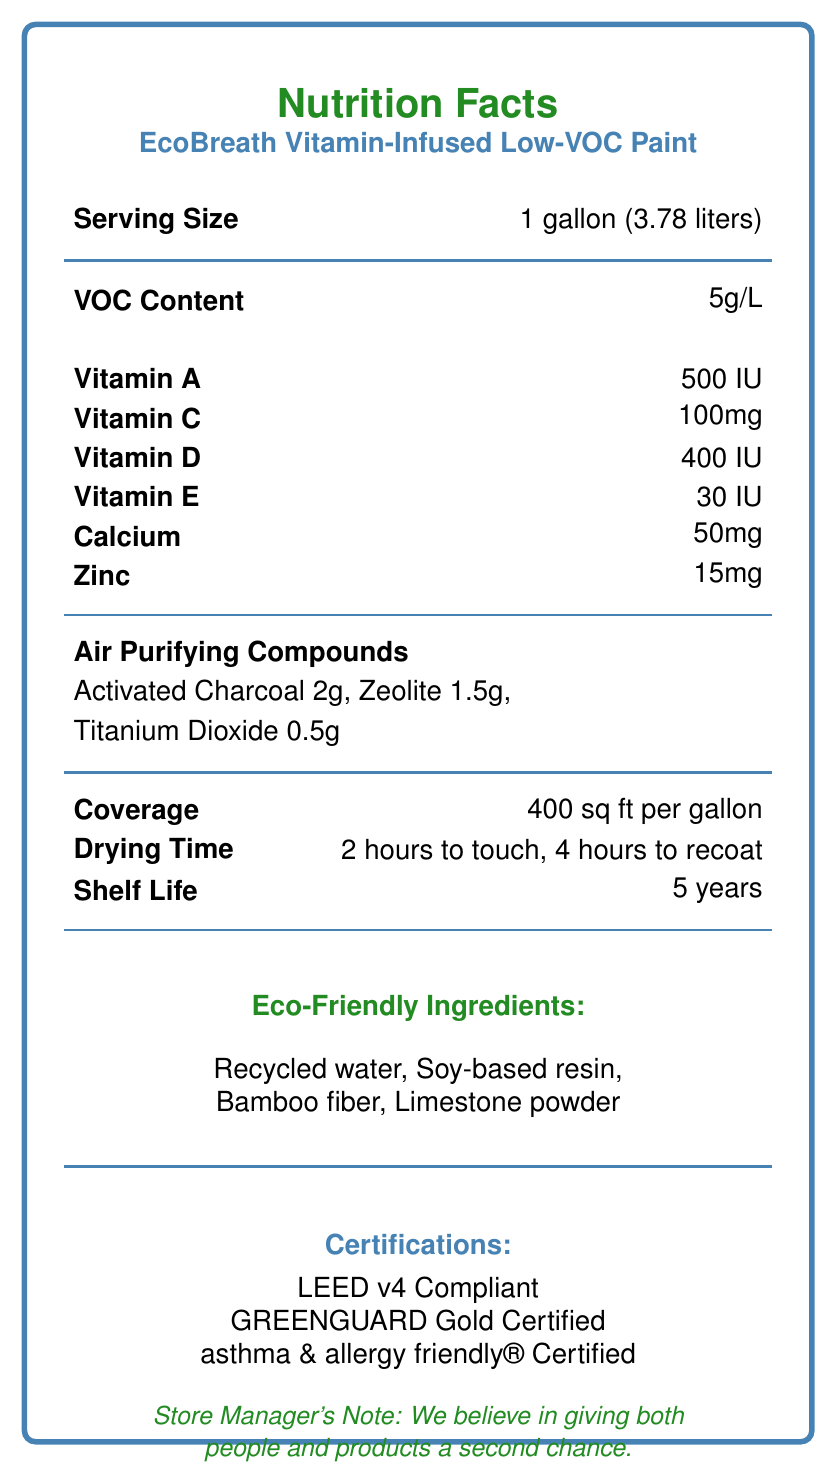what is the VOC content of the paint? The VOC content is listed under the "VOC Content" section in the document.
Answer: 5g/L what is the serving size for this paint? The serving size is listed as "1 gallon (3.78 liters)" in the document.
Answer: 1 gallon (3.78 liters) how many vitamins are listed in the nutrition facts? The nutrition facts list Vitamin A, Vitamin C, Vitamin D, and Vitamin E.
Answer: 4 how long does it take for the paint to dry to touch? The drying time to touch is stated as "2 hours" under the "Drying Time" section.
Answer: 2 hours where is the paint made? The document indicates that the paint is made in the USA.
Answer: USA which of these is not listed as an air purifying compound in the paint? A. Activated Charcoal B. Zeolite C. Bamboo Fiber D. Titanium Dioxide The document lists Activated Charcoal, Zeolite, and Titanium Dioxide as air purifying compounds but not Bamboo Fiber.
Answer: C. Bamboo Fiber which certification is not mentioned in the document? A. LEED v4 Compliant B. GREENGUARD Gold Certified C. asthma & allergy friendly® Certified D. ENERGY STAR The certifications listed are LEED v4 Compliant, GREENGUARD Gold Certified, and asthma & allergy friendly® Certified but not ENERGY STAR.
Answer: D. ENERGY STAR is this paint eco-friendly? The paint contains eco-friendly ingredients such as recycled water, soy-based resin, bamboo fiber, and limestone powder and is LEED v4 Compliant and GREENGUARD Gold Certified.
Answer: Yes describe the main idea of the document. The document aims to highlight the benefits and eco-friendly features of the paint, including its low-VOC content, vitamin infusion, and green certifications. In addition, it reflects the store's philosophy of supporting second chances in life.
Answer: The document provides the nutrition facts and other key information about EcoBreath Vitamin-Infused Low-VOC Paint. It details the serving size, vitamins content, VOC content, eco-friendly ingredients, air purifying compounds, coverage area, drying time, shelf life, certifications, recycled content, and country of manufacture. It includes a note from the store manager emphasizing giving people and products a second chance. what is the total calorie content per serving? The document states that the paint has 0 calories, indicating it is not used for consumption.
Answer: 0 calories what is the zinc content per gallon? The zinc content is listed as "15mg" in the nutrition facts section.
Answer: 15mg can this document provide information on the price of the paint? The document does not include any pricing information.
Answer: Not enough information what type of resin is mentioned under the eco-friendly ingredients? The eco-friendly ingredients include soy-based resin.
Answer: Soy-based resin how many square feet can one gallon of this paint cover? The coverage is listed as "400 sq ft per gallon" in the document.
Answer: 400 sq ft 